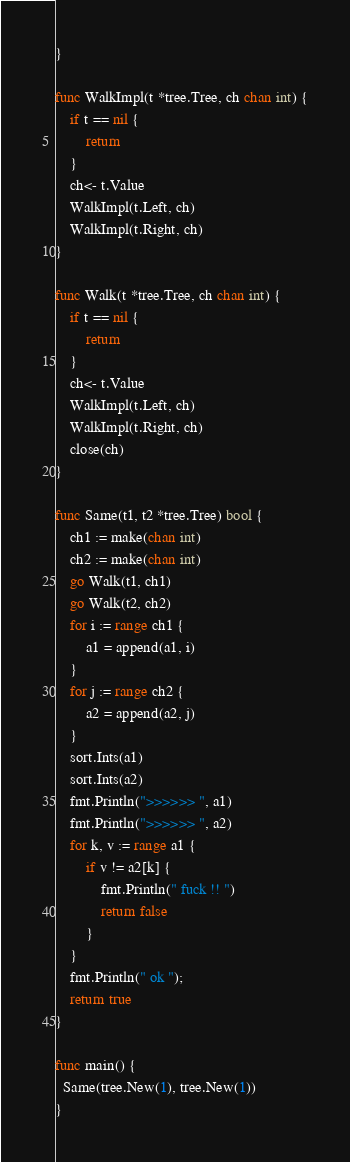<code> <loc_0><loc_0><loc_500><loc_500><_Go_>}

func WalkImpl(t *tree.Tree, ch chan int) {
	if t == nil {
		return
	}
	ch<- t.Value
	WalkImpl(t.Left, ch)
	WalkImpl(t.Right, ch)
}

func Walk(t *tree.Tree, ch chan int) {
	if t == nil {
		return
	}
	ch<- t.Value
	WalkImpl(t.Left, ch)
	WalkImpl(t.Right, ch)
	close(ch)
}

func Same(t1, t2 *tree.Tree) bool {
	ch1 := make(chan int)
	ch2 := make(chan int)
	go Walk(t1, ch1)
	go Walk(t2, ch2)
	for i := range ch1 {
		a1 = append(a1, i)
	}
	for j := range ch2 {
		a2 = append(a2, j)
	}
	sort.Ints(a1)
	sort.Ints(a2)
	fmt.Println(">>>>>> ", a1)
	fmt.Println(">>>>>> ", a2)
	for k, v := range a1 {
		if v != a2[k] {
			fmt.Println(" fuck !! ")
			return false
		}
	}
	fmt.Println(" ok ");
	return true
}

func main() {
  Same(tree.New(1), tree.New(1))
}
</code> 